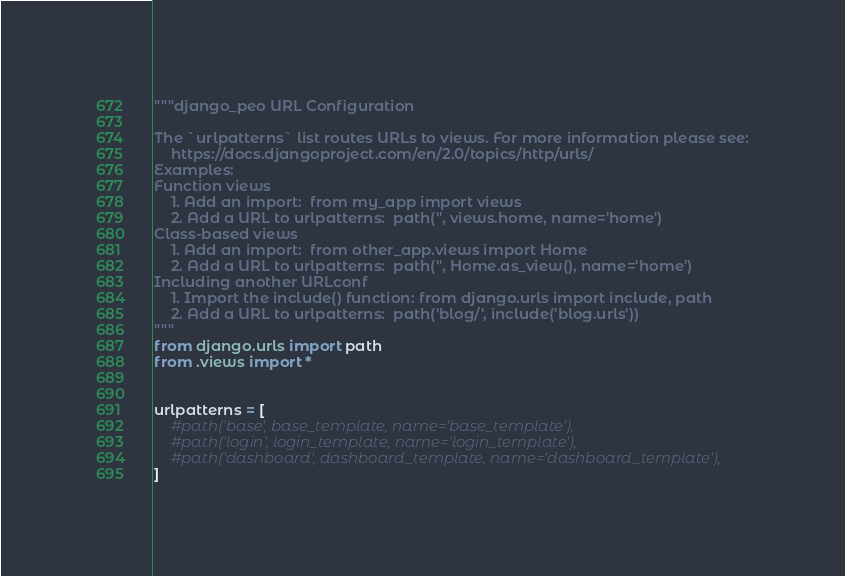Convert code to text. <code><loc_0><loc_0><loc_500><loc_500><_Python_>"""django_peo URL Configuration

The `urlpatterns` list routes URLs to views. For more information please see:
    https://docs.djangoproject.com/en/2.0/topics/http/urls/
Examples:
Function views
    1. Add an import:  from my_app import views
    2. Add a URL to urlpatterns:  path('', views.home, name='home')
Class-based views
    1. Add an import:  from other_app.views import Home
    2. Add a URL to urlpatterns:  path('', Home.as_view(), name='home')
Including another URLconf
    1. Import the include() function: from django.urls import include, path
    2. Add a URL to urlpatterns:  path('blog/', include('blog.urls'))
"""
from django.urls import path
from .views import *


urlpatterns = [
    #path('base', base_template, name='base_template'),
    #path('login', login_template, name='login_template'),
    #path('dashboard', dashboard_template, name='dashboard_template'),
]
</code> 